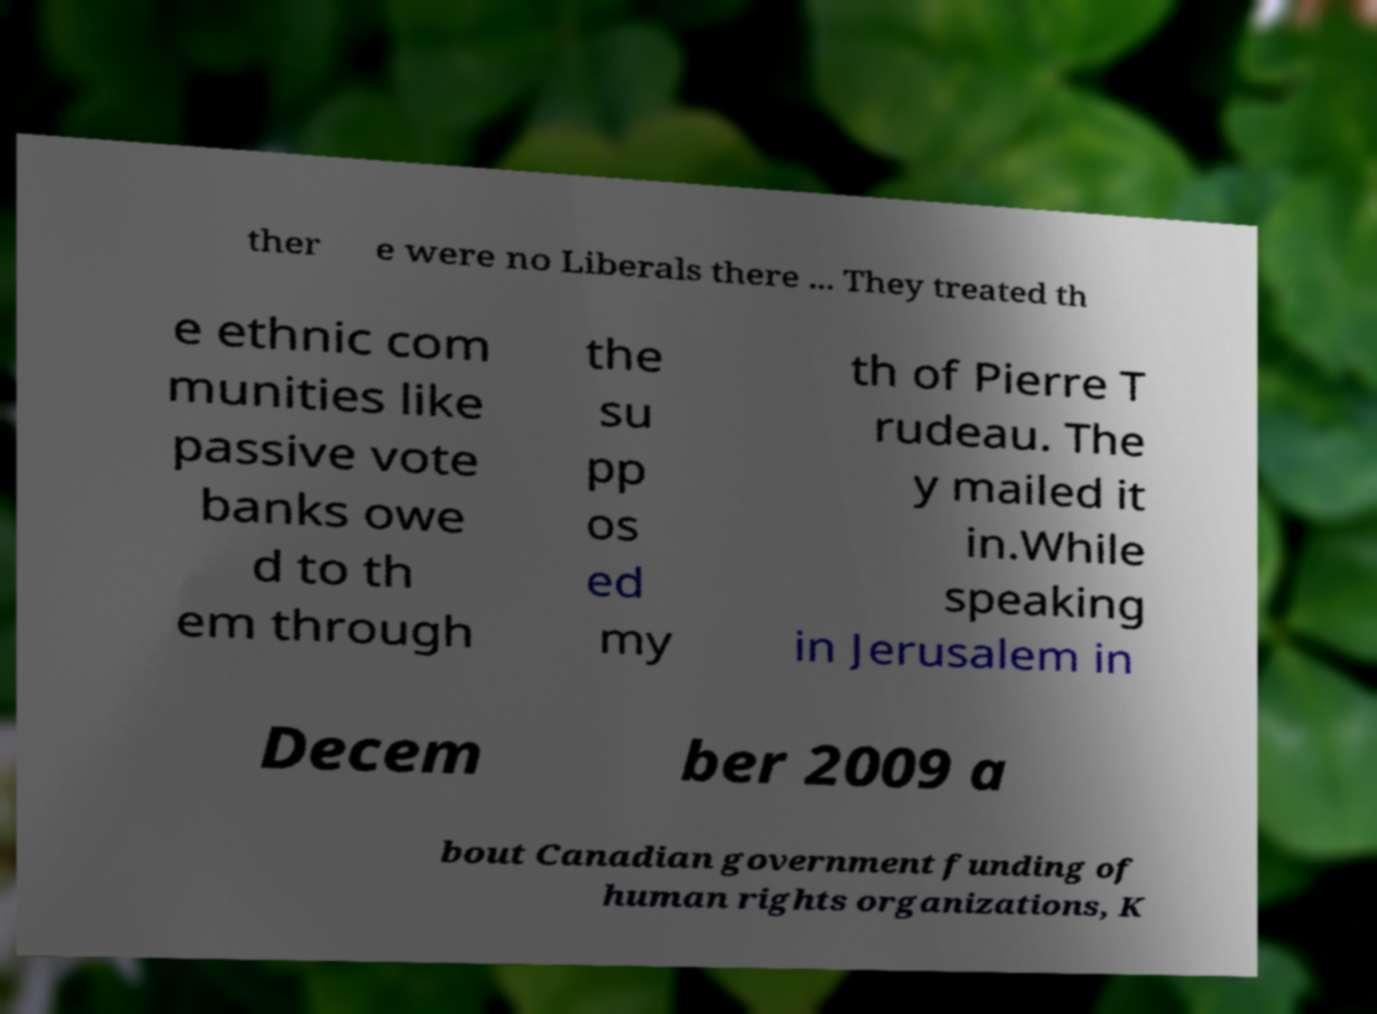I need the written content from this picture converted into text. Can you do that? ther e were no Liberals there ... They treated th e ethnic com munities like passive vote banks owe d to th em through the su pp os ed my th of Pierre T rudeau. The y mailed it in.While speaking in Jerusalem in Decem ber 2009 a bout Canadian government funding of human rights organizations, K 